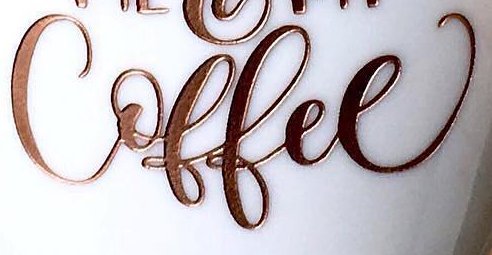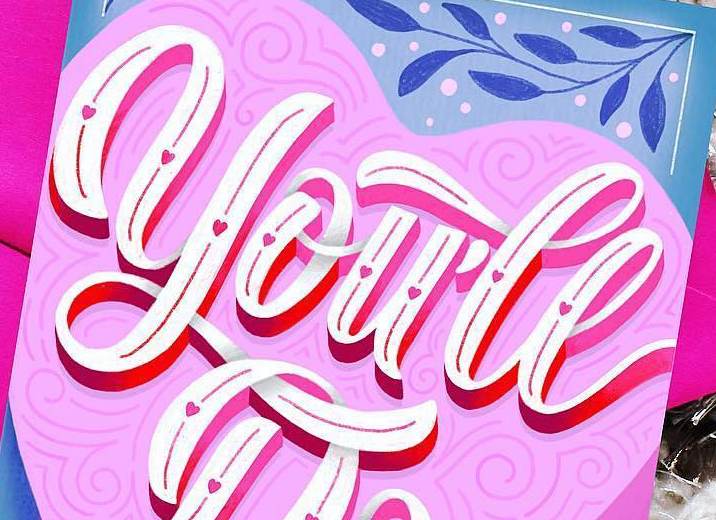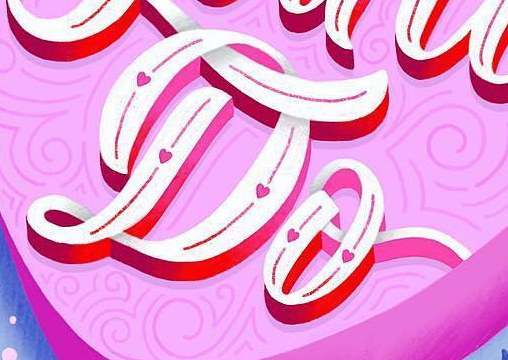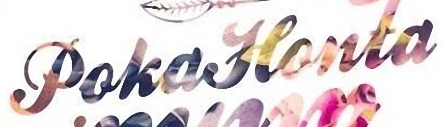Identify the words shown in these images in order, separated by a semicolon. Coffee; you'll; Do; PokaHonta 